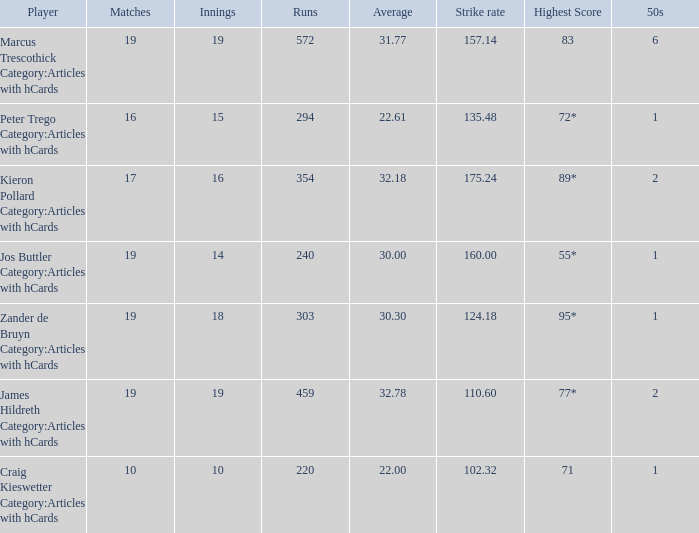61 average? 15.0. 